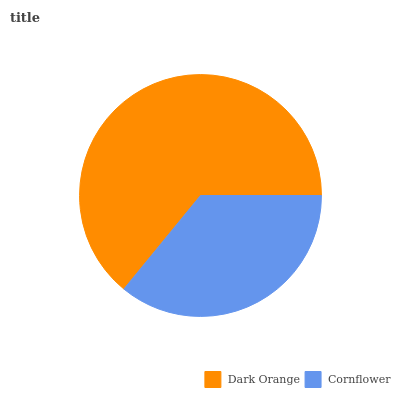Is Cornflower the minimum?
Answer yes or no. Yes. Is Dark Orange the maximum?
Answer yes or no. Yes. Is Cornflower the maximum?
Answer yes or no. No. Is Dark Orange greater than Cornflower?
Answer yes or no. Yes. Is Cornflower less than Dark Orange?
Answer yes or no. Yes. Is Cornflower greater than Dark Orange?
Answer yes or no. No. Is Dark Orange less than Cornflower?
Answer yes or no. No. Is Dark Orange the high median?
Answer yes or no. Yes. Is Cornflower the low median?
Answer yes or no. Yes. Is Cornflower the high median?
Answer yes or no. No. Is Dark Orange the low median?
Answer yes or no. No. 